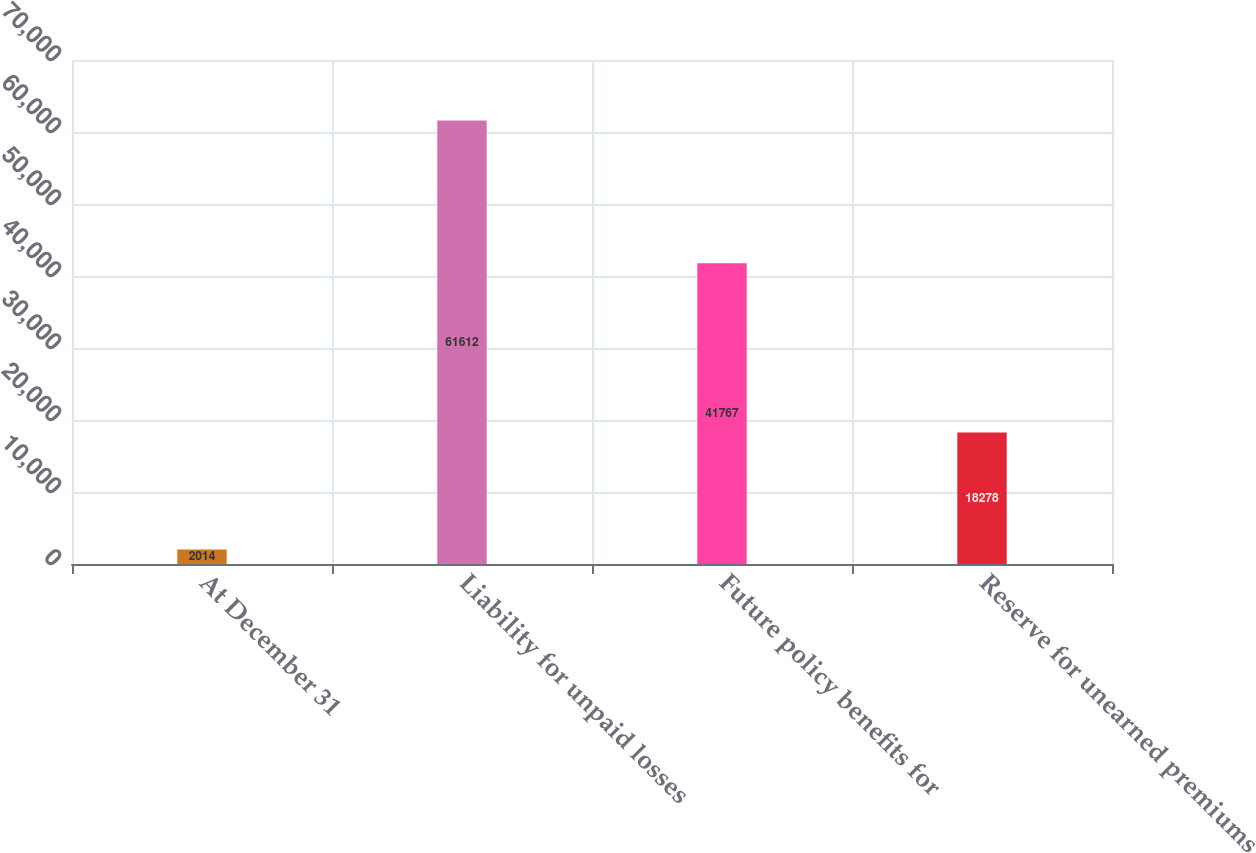Convert chart. <chart><loc_0><loc_0><loc_500><loc_500><bar_chart><fcel>At December 31<fcel>Liability for unpaid losses<fcel>Future policy benefits for<fcel>Reserve for unearned premiums<nl><fcel>2014<fcel>61612<fcel>41767<fcel>18278<nl></chart> 